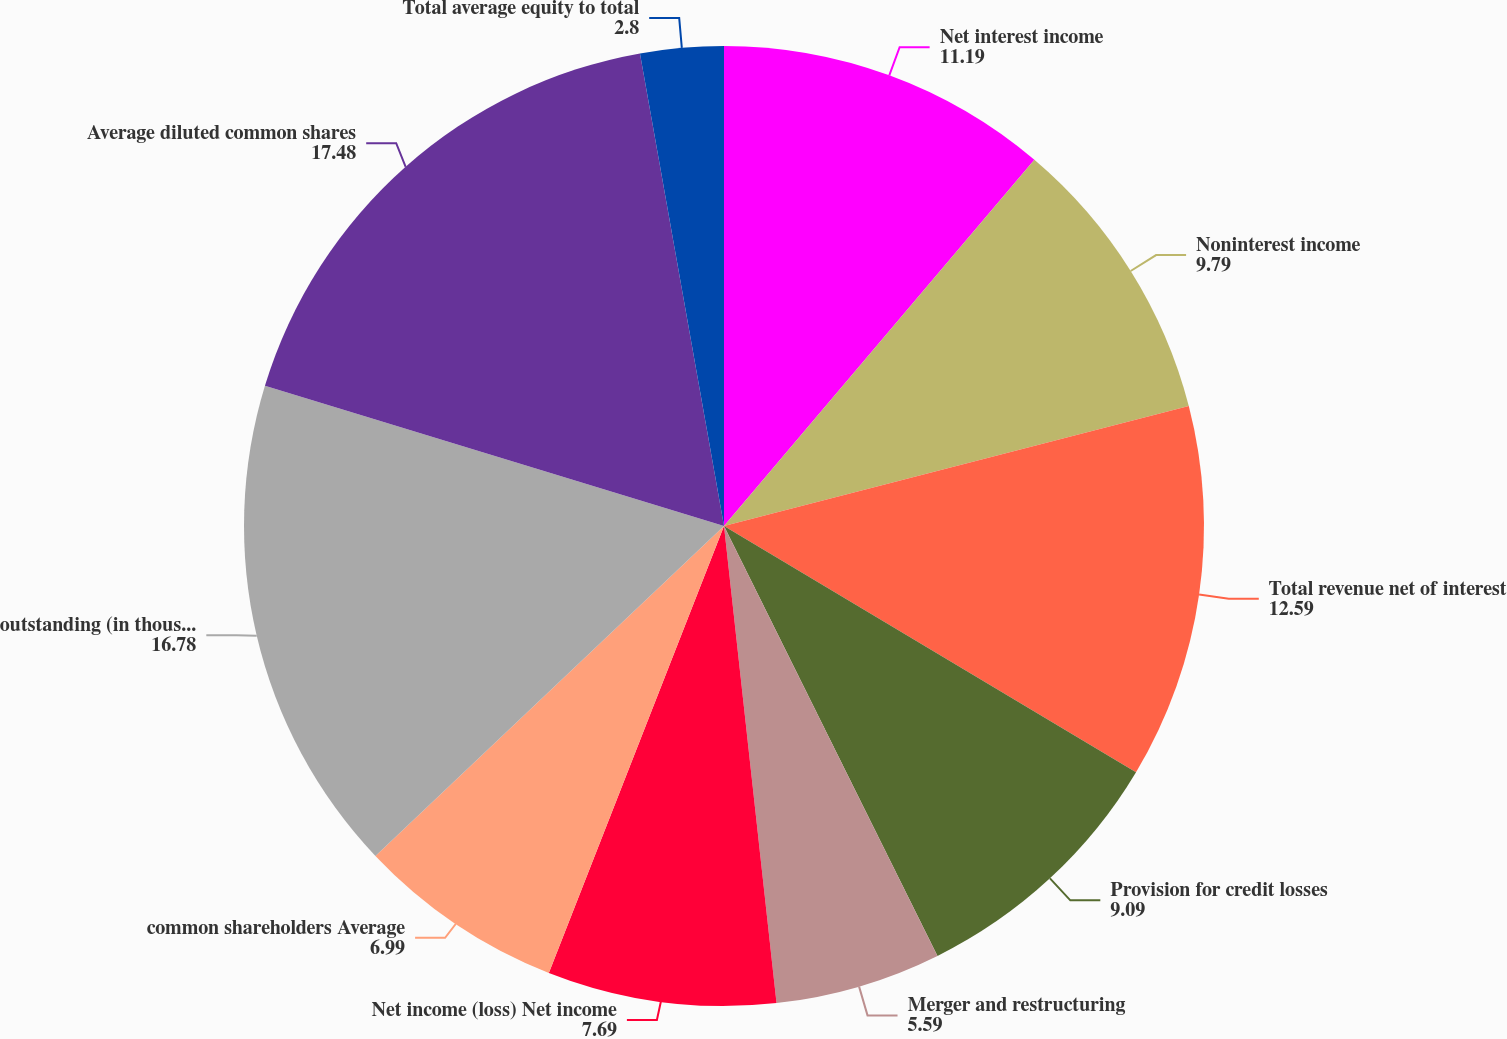<chart> <loc_0><loc_0><loc_500><loc_500><pie_chart><fcel>Net interest income<fcel>Noninterest income<fcel>Total revenue net of interest<fcel>Provision for credit losses<fcel>Merger and restructuring<fcel>Net income (loss) Net income<fcel>common shareholders Average<fcel>outstanding (in thousands)<fcel>Average diluted common shares<fcel>Total average equity to total<nl><fcel>11.19%<fcel>9.79%<fcel>12.59%<fcel>9.09%<fcel>5.59%<fcel>7.69%<fcel>6.99%<fcel>16.78%<fcel>17.48%<fcel>2.8%<nl></chart> 